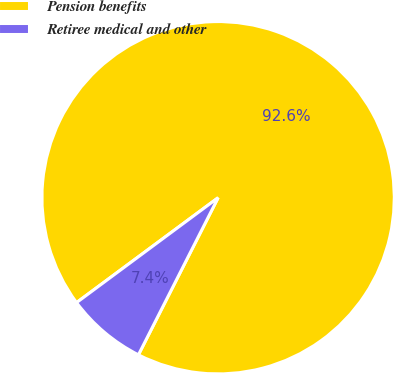<chart> <loc_0><loc_0><loc_500><loc_500><pie_chart><fcel>Pension benefits<fcel>Retiree medical and other<nl><fcel>92.62%<fcel>7.38%<nl></chart> 